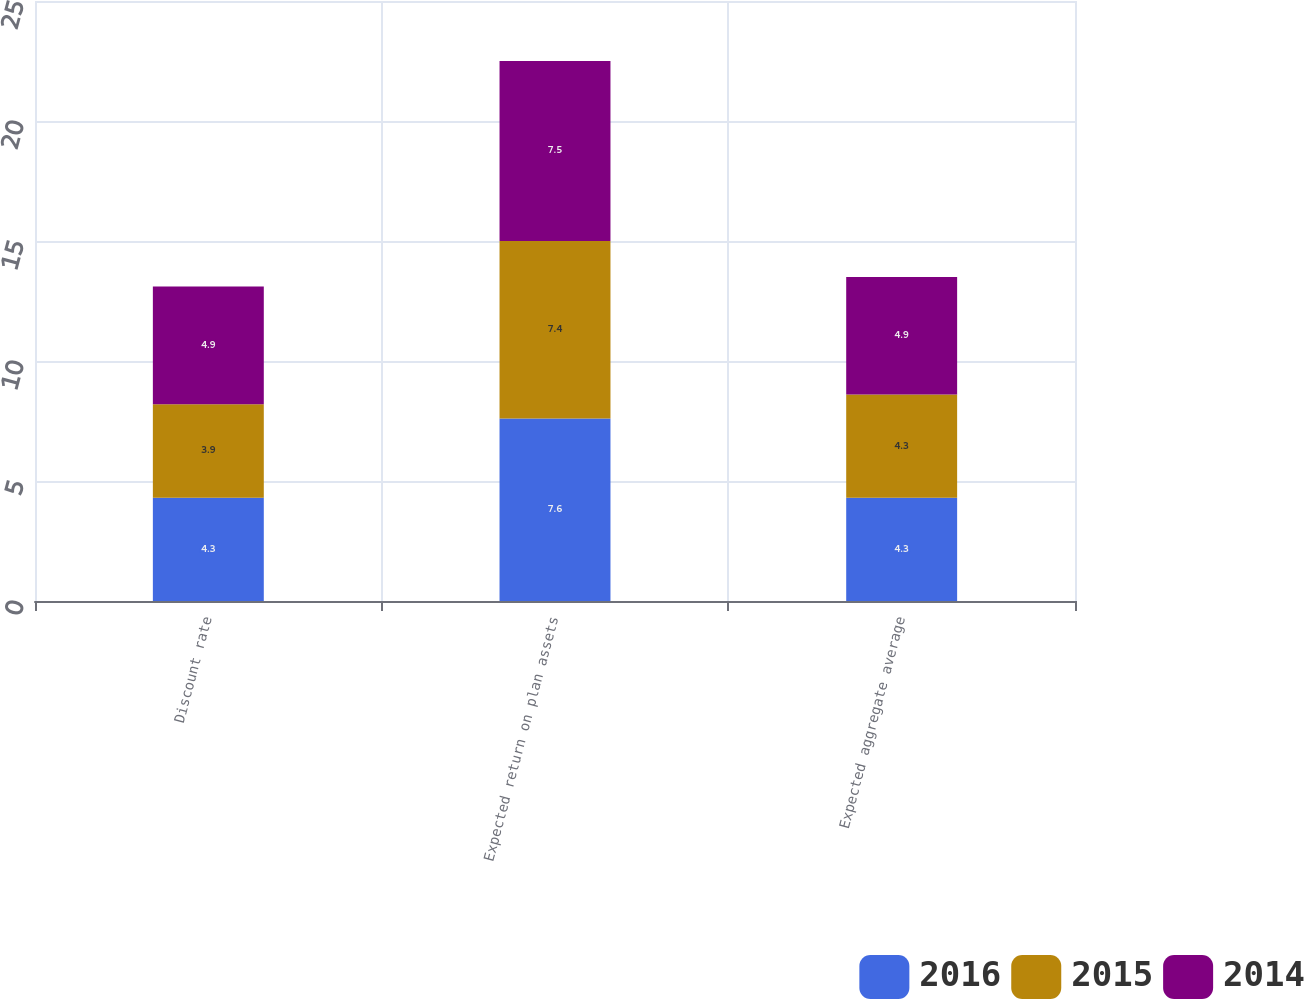<chart> <loc_0><loc_0><loc_500><loc_500><stacked_bar_chart><ecel><fcel>Discount rate<fcel>Expected return on plan assets<fcel>Expected aggregate average<nl><fcel>2016<fcel>4.3<fcel>7.6<fcel>4.3<nl><fcel>2015<fcel>3.9<fcel>7.4<fcel>4.3<nl><fcel>2014<fcel>4.9<fcel>7.5<fcel>4.9<nl></chart> 